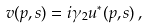Convert formula to latex. <formula><loc_0><loc_0><loc_500><loc_500>v ( p , s ) = i \gamma _ { 2 } u ^ { * } ( p , s ) \, ,</formula> 